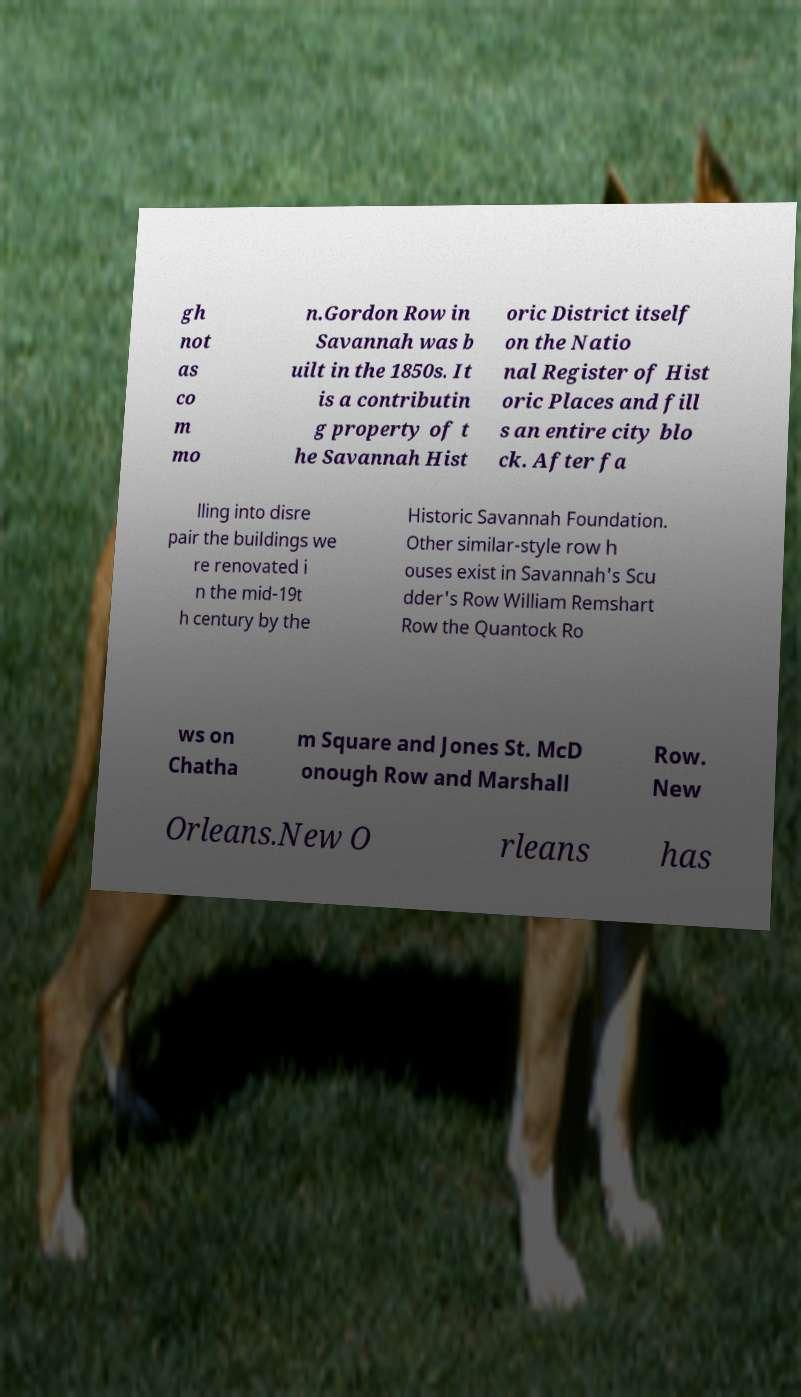Can you accurately transcribe the text from the provided image for me? gh not as co m mo n.Gordon Row in Savannah was b uilt in the 1850s. It is a contributin g property of t he Savannah Hist oric District itself on the Natio nal Register of Hist oric Places and fill s an entire city blo ck. After fa lling into disre pair the buildings we re renovated i n the mid-19t h century by the Historic Savannah Foundation. Other similar-style row h ouses exist in Savannah's Scu dder's Row William Remshart Row the Quantock Ro ws on Chatha m Square and Jones St. McD onough Row and Marshall Row. New Orleans.New O rleans has 